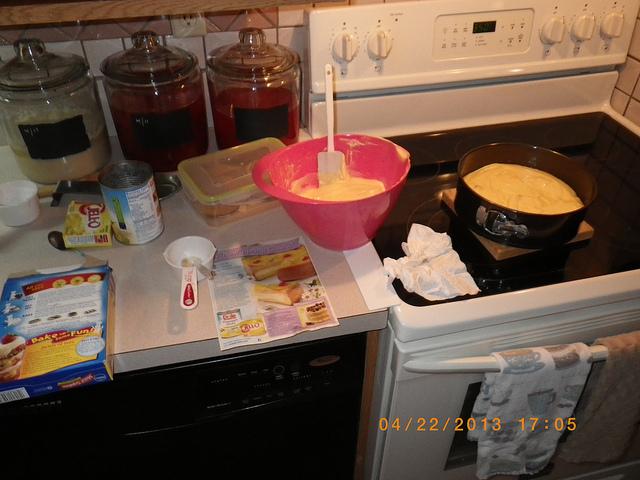What time was this photo taken?
Keep it brief. 17:05. Is that a tea kettle?
Answer briefly. No. Is the food ready to eat?
Quick response, please. No. How many jars are visible?
Write a very short answer. 3. Is the cooker on?
Short answer required. No. Is there food coloring in this cake?
Concise answer only. No. Is there cooking oil on the counter?
Answer briefly. No. What type of food is she making?
Quick response, please. Cake. 